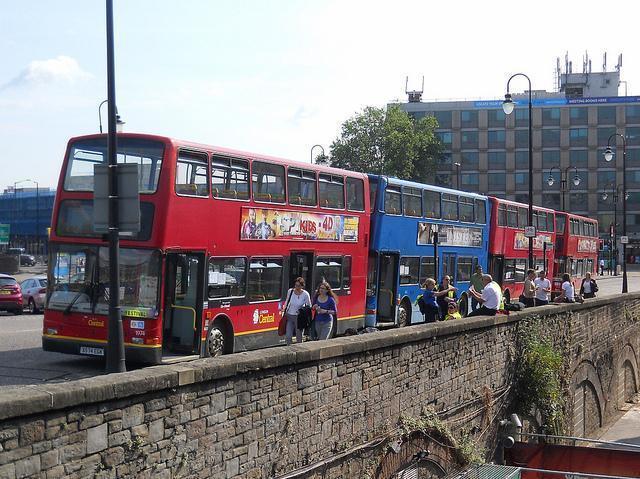Who is the queen of this territory?
Choose the right answer and clarify with the format: 'Answer: answer
Rationale: rationale.'
Options: Milena trump, elizabeth ii, lukashenko, ivanka trump. Answer: elizabeth ii.
Rationale: Due to the double decker buses it's easy to surmise what country this is. 